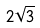Convert formula to latex. <formula><loc_0><loc_0><loc_500><loc_500>2 \sqrt { 3 }</formula> 